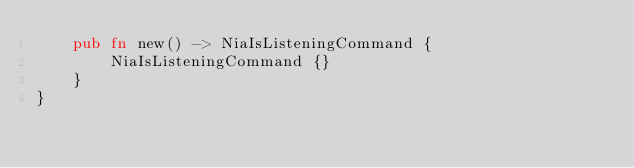<code> <loc_0><loc_0><loc_500><loc_500><_Rust_>    pub fn new() -> NiaIsListeningCommand {
        NiaIsListeningCommand {}
    }
}
</code> 